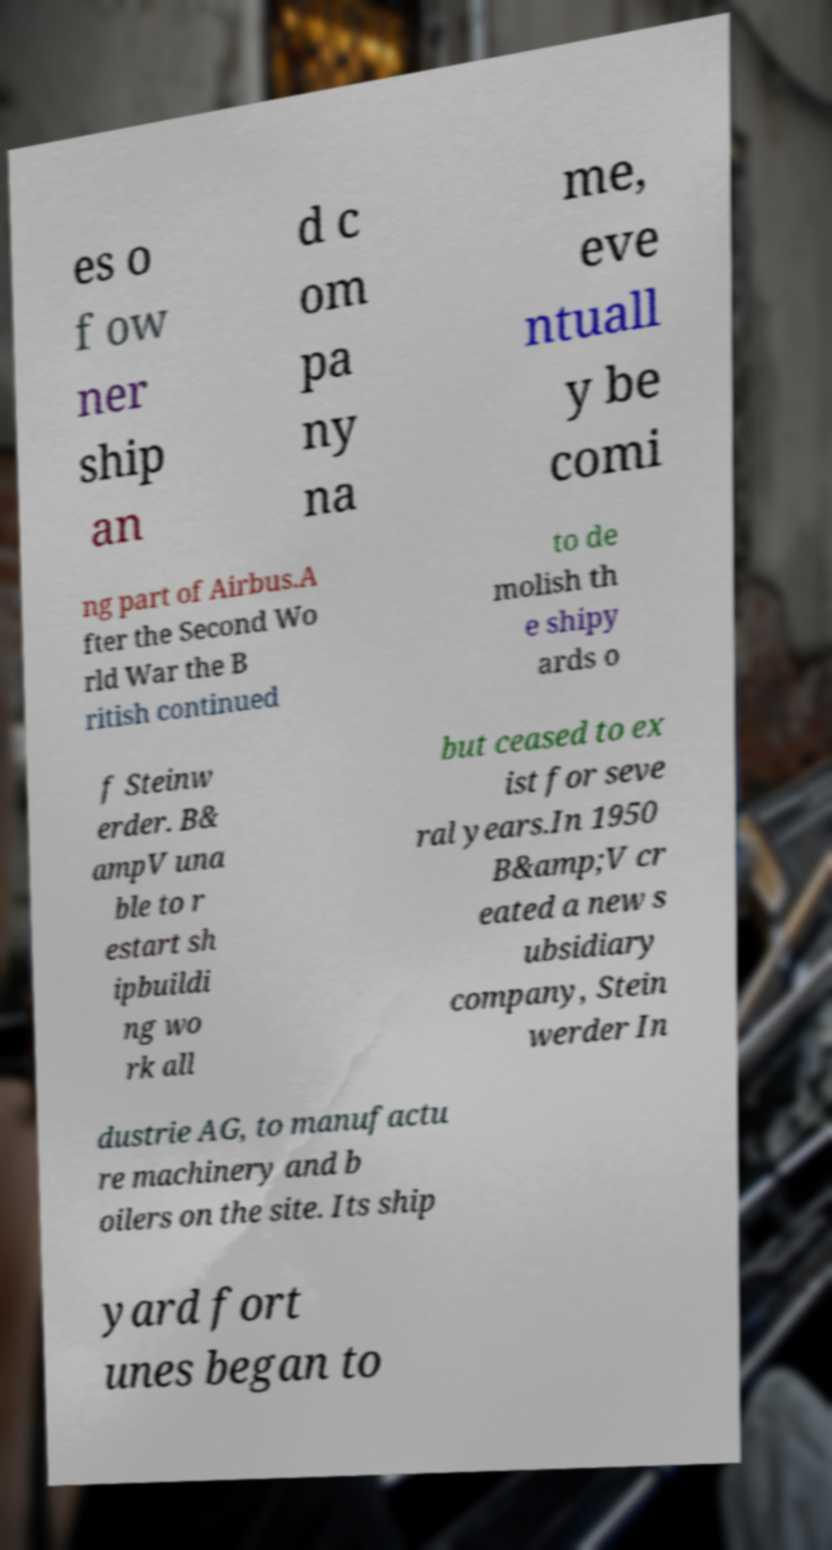Please read and relay the text visible in this image. What does it say? es o f ow ner ship an d c om pa ny na me, eve ntuall y be comi ng part of Airbus.A fter the Second Wo rld War the B ritish continued to de molish th e shipy ards o f Steinw erder. B& ampV una ble to r estart sh ipbuildi ng wo rk all but ceased to ex ist for seve ral years.In 1950 B&amp;V cr eated a new s ubsidiary company, Stein werder In dustrie AG, to manufactu re machinery and b oilers on the site. Its ship yard fort unes began to 